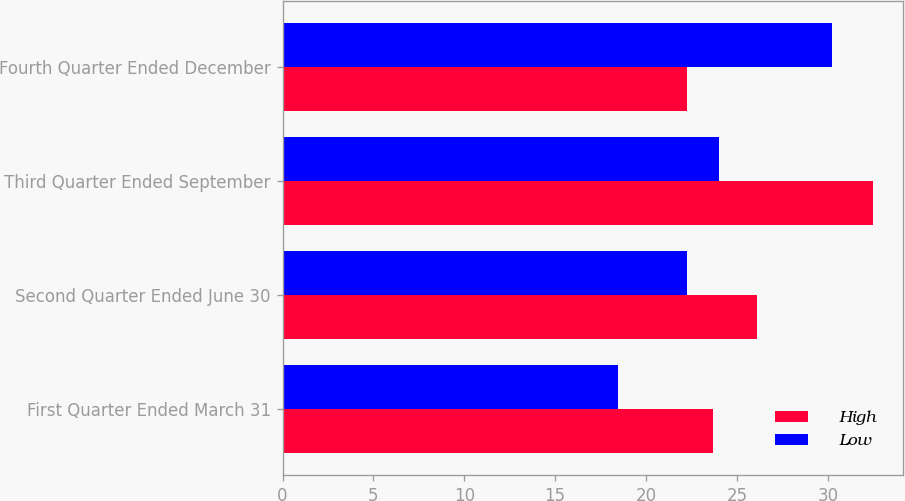Convert chart to OTSL. <chart><loc_0><loc_0><loc_500><loc_500><stacked_bar_chart><ecel><fcel>First Quarter Ended March 31<fcel>Second Quarter Ended June 30<fcel>Third Quarter Ended September<fcel>Fourth Quarter Ended December<nl><fcel>High<fcel>23.69<fcel>26.09<fcel>32.5<fcel>22.28<nl><fcel>Low<fcel>18.43<fcel>22.28<fcel>24.04<fcel>30.25<nl></chart> 